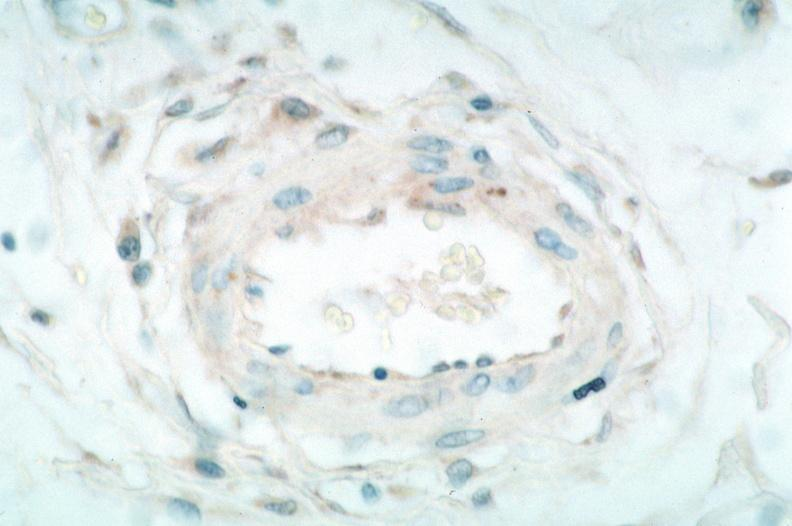what is present?
Answer the question using a single word or phrase. Cardiovascular 